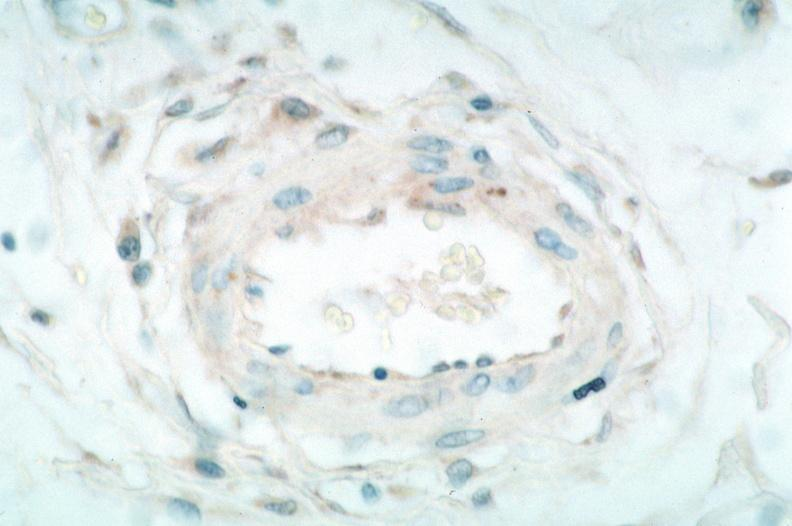what is present?
Answer the question using a single word or phrase. Cardiovascular 